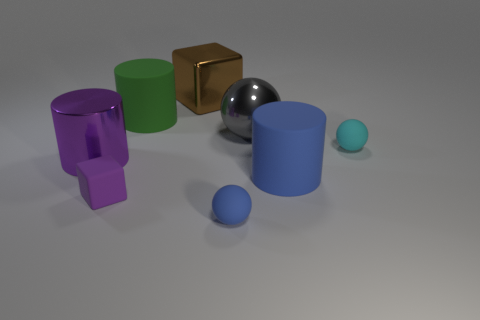The tiny thing that is the same color as the big metallic cylinder is what shape?
Ensure brevity in your answer.  Cube. What is the shape of the small blue object?
Give a very brief answer. Sphere. Is the rubber cube the same color as the metal cylinder?
Offer a very short reply. Yes. How many objects are either big rubber objects behind the metallic ball or gray spheres?
Provide a short and direct response. 2. What size is the green thing that is the same material as the big blue cylinder?
Your answer should be very brief. Large. Is the number of brown blocks that are on the right side of the large brown metallic thing greater than the number of big brown metal things?
Your answer should be very brief. No. There is a large brown thing; is its shape the same as the matte object behind the cyan matte object?
Your response must be concise. No. How many big objects are either cyan matte cylinders or green rubber cylinders?
Give a very brief answer. 1. There is a object that is the same color as the large shiny cylinder; what is its size?
Provide a succinct answer. Small. There is a block that is in front of the rubber ball that is on the right side of the tiny blue thing; what is its color?
Offer a terse response. Purple. 